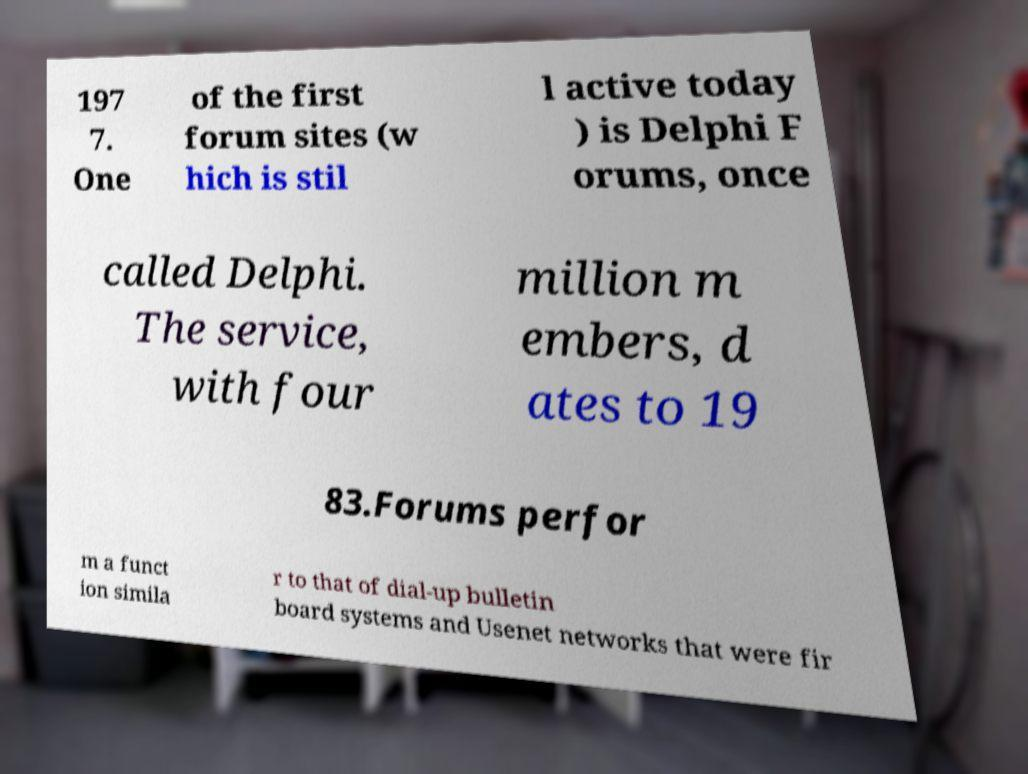Can you accurately transcribe the text from the provided image for me? 197 7. One of the first forum sites (w hich is stil l active today ) is Delphi F orums, once called Delphi. The service, with four million m embers, d ates to 19 83.Forums perfor m a funct ion simila r to that of dial-up bulletin board systems and Usenet networks that were fir 